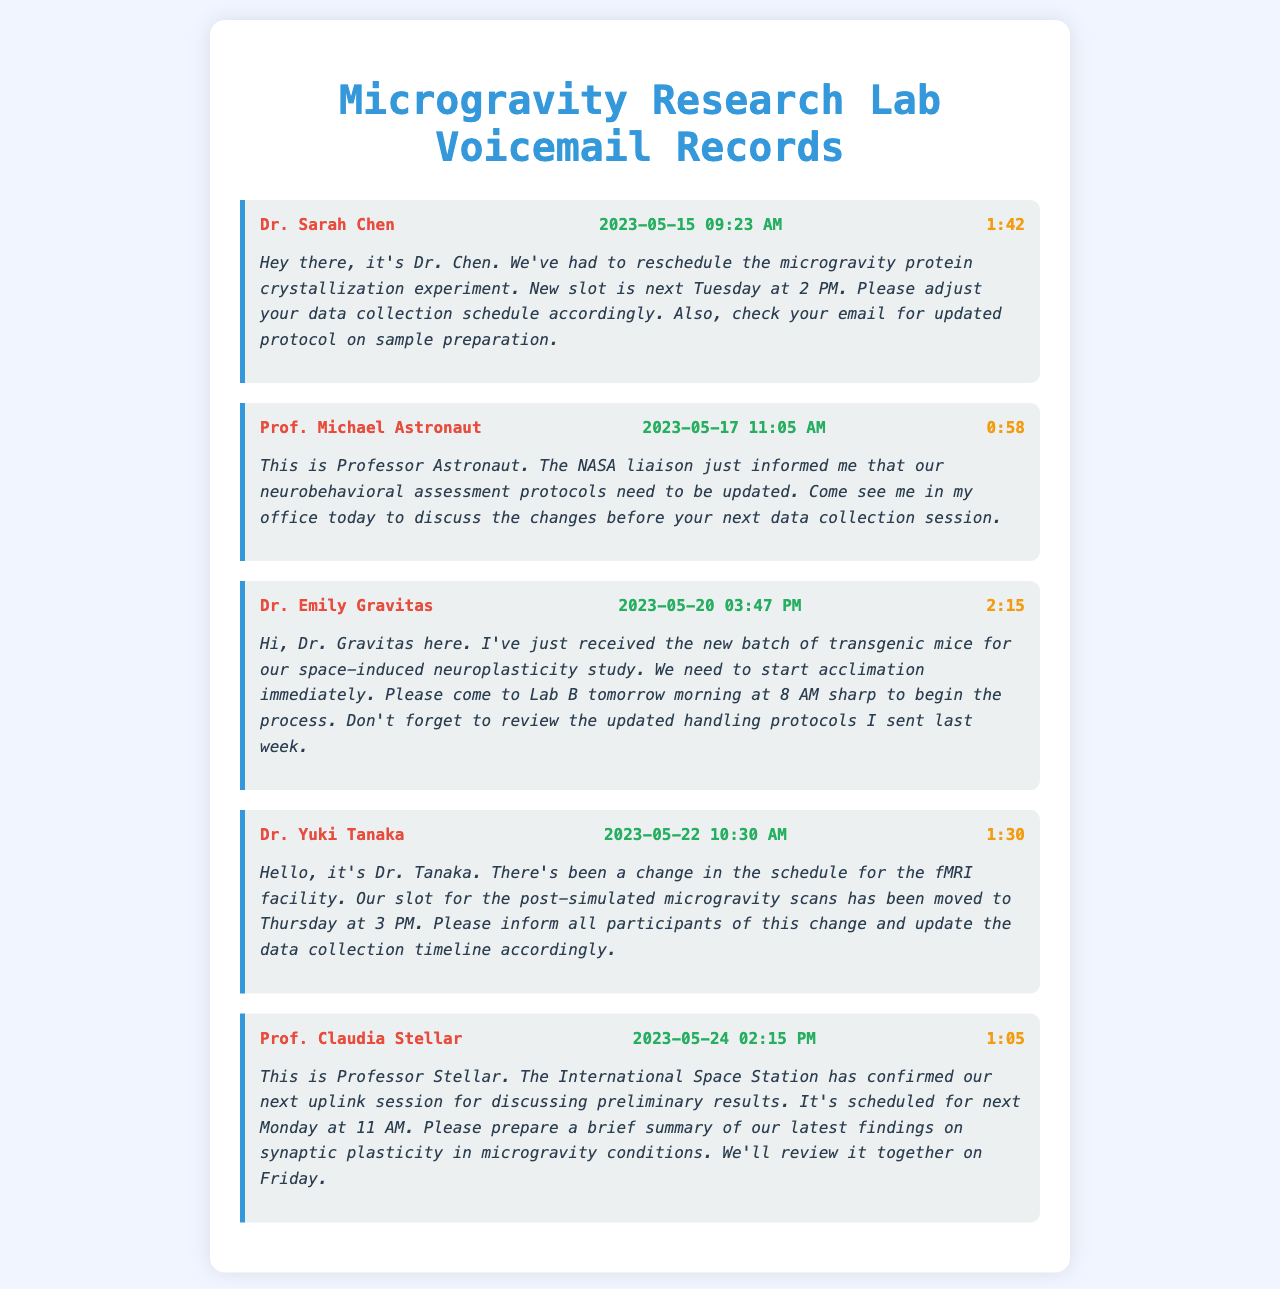what is the date of Dr. Sarah Chen's voicemail? The date of Dr. Sarah Chen's voicemail is clearly stated in her voicemail header.
Answer: 2023-05-15 who called regarding the neurobehavioral assessment protocols? The voicemail from Professor Astronaut addresses the update on the neurobehavioral assessment protocols.
Answer: Prof. Michael Astronaut what is the duration of Dr. Emily Gravitas's message? The duration is listed in the voicemail header for Dr. Emily Gravitas's message.
Answer: 2:15 when is the acclimation process for the transgenic mice scheduled to start? The voicemail from Dr. Emily Gravitas specifies the starting time for the acclimation process.
Answer: tomorrow morning at 8 AM what is the new date for the fMRI facility scans? Dr. Yuki Tanaka's voicemail mentions the rescheduled date for the fMRI scans.
Answer: Thursday at 3 PM how many days are between the voicemails from Dr. Sarah Chen and Prof. Michael Astronaut? The dates of the voicemails are known, allowing for the calculation of the days in between.
Answer: 2 days what protocol should be reviewed based on Dr. Gravitas's voicemail? Dr. Gravitas specifically mentions the handling protocols that need to be reviewed.
Answer: updated handling protocols when is the uplink session scheduled with the International Space Station? Professor Stellar's voicemail includes the date for the uplink session.
Answer: next Monday at 11 AM who is the first caller in the voicemail records? The first voicemail listed in the document identifies the caller.
Answer: Dr. Sarah Chen 